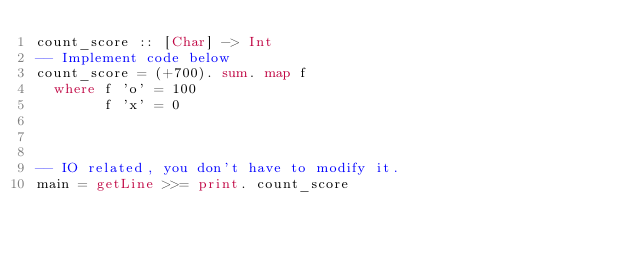<code> <loc_0><loc_0><loc_500><loc_500><_Haskell_>count_score :: [Char] -> Int
-- Implement code below
count_score = (+700). sum. map f
  where f 'o' = 100
        f 'x' = 0



-- IO related, you don't have to modify it.
main = getLine >>= print. count_score
</code> 